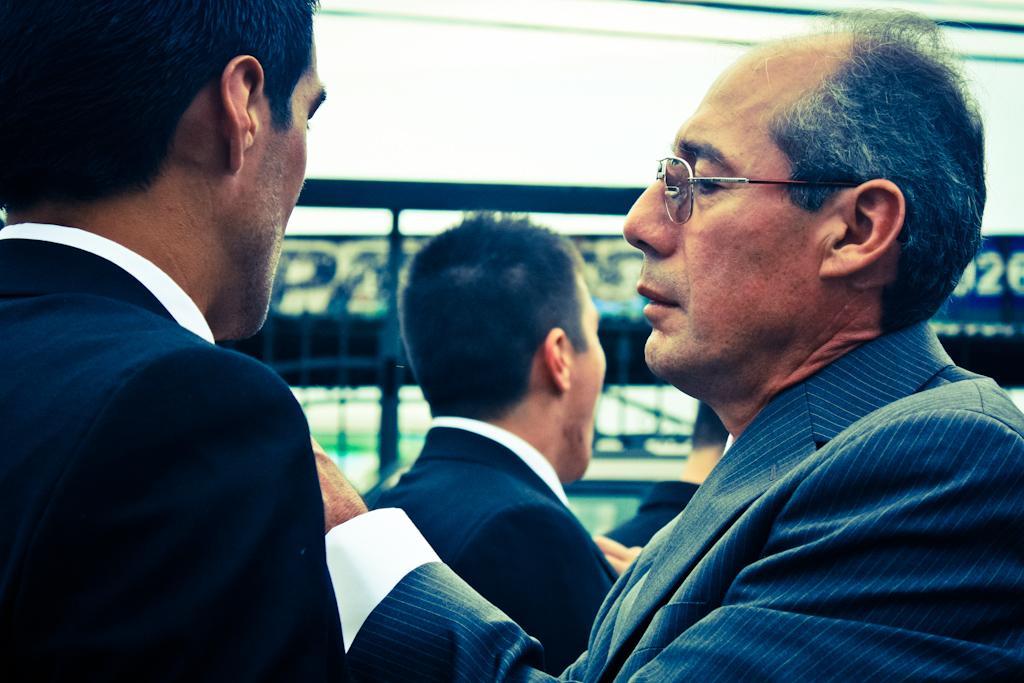Can you describe this image briefly? This image is taken outdoors. In the background there is a board with a text on it and there are a few iron bars. In the middle of the image there are four men. They have worn suits and shirts. 